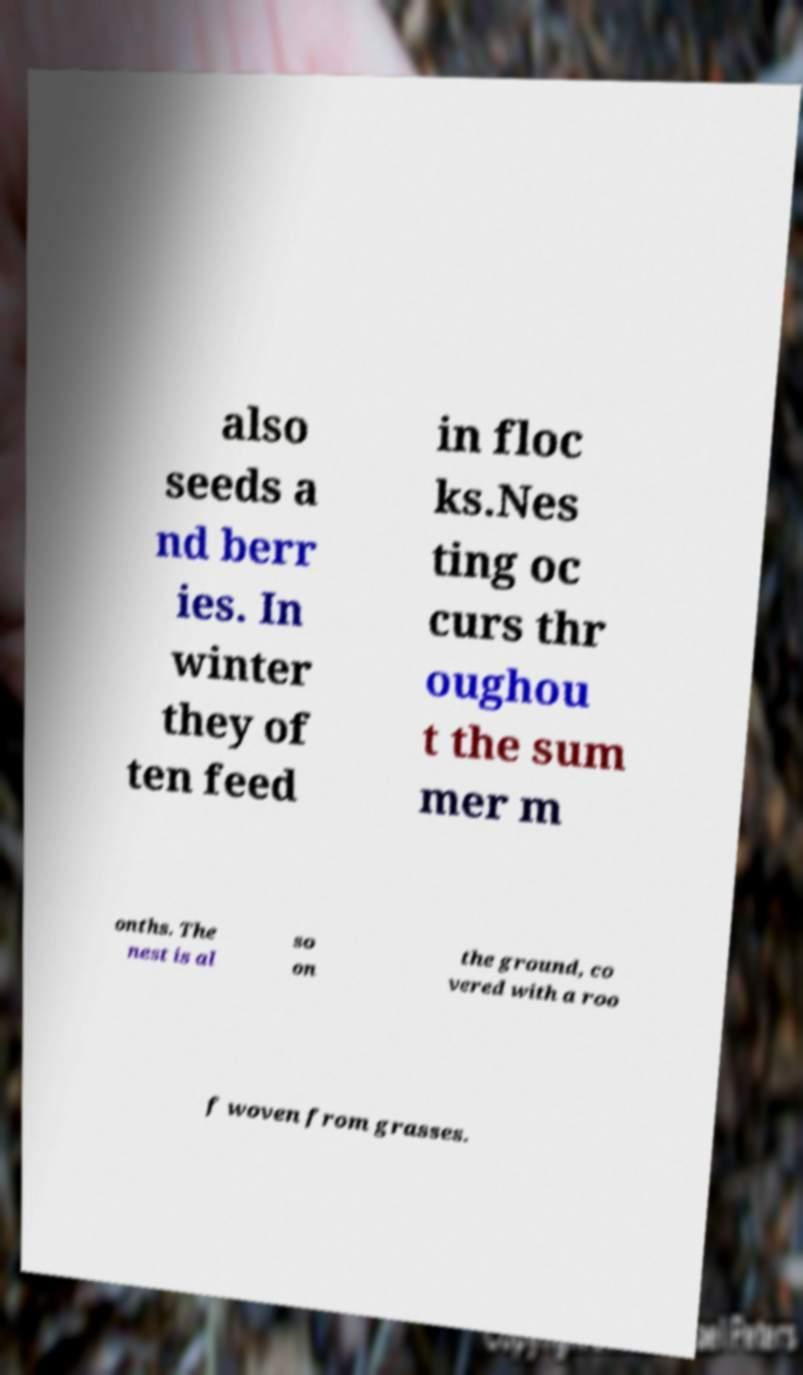Could you assist in decoding the text presented in this image and type it out clearly? also seeds a nd berr ies. In winter they of ten feed in floc ks.Nes ting oc curs thr oughou t the sum mer m onths. The nest is al so on the ground, co vered with a roo f woven from grasses. 